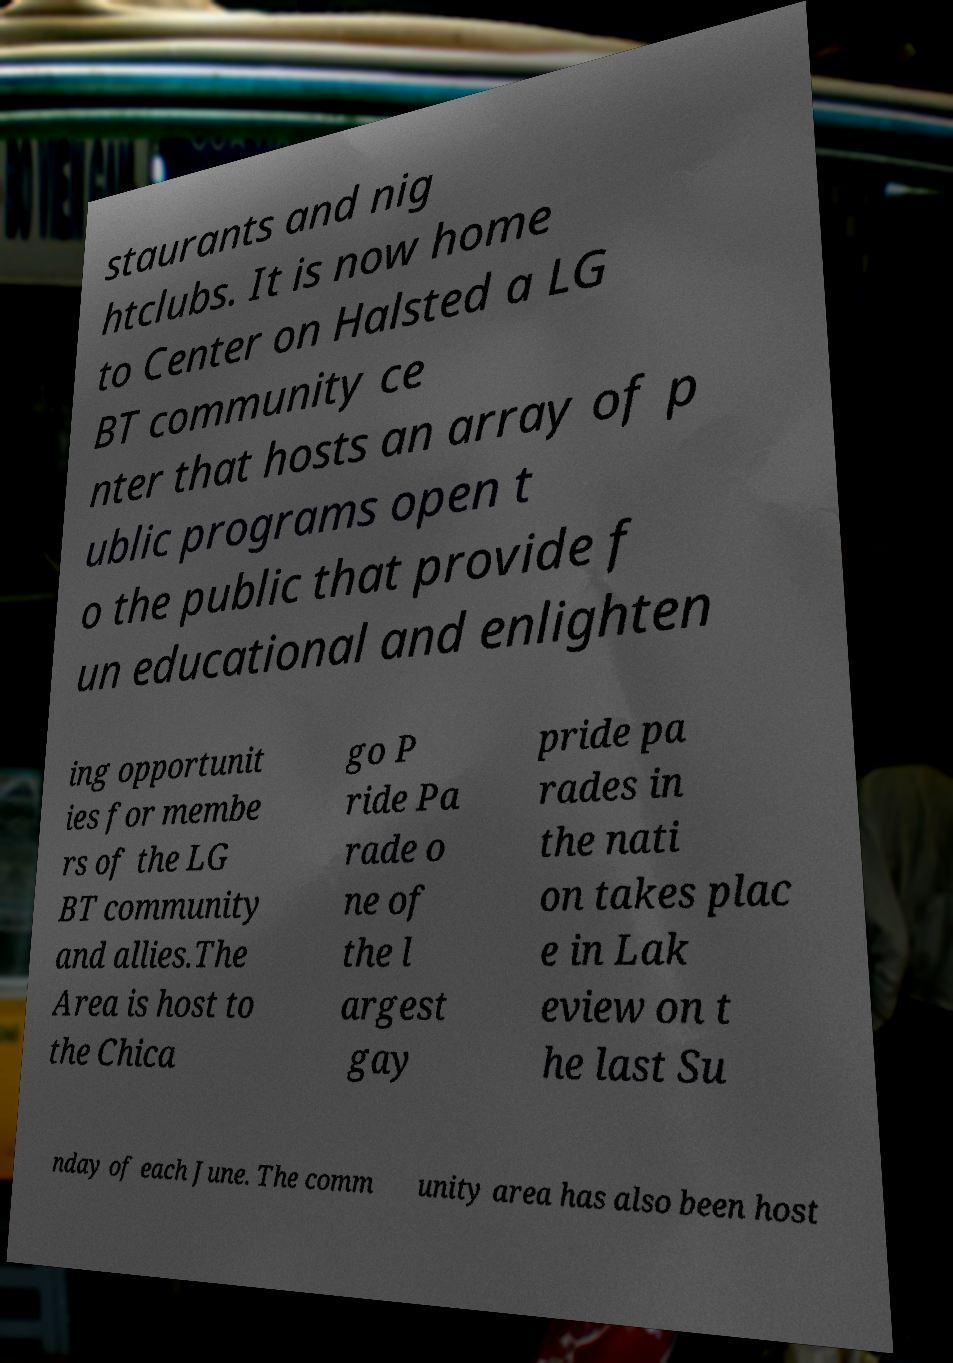What messages or text are displayed in this image? I need them in a readable, typed format. staurants and nig htclubs. It is now home to Center on Halsted a LG BT community ce nter that hosts an array of p ublic programs open t o the public that provide f un educational and enlighten ing opportunit ies for membe rs of the LG BT community and allies.The Area is host to the Chica go P ride Pa rade o ne of the l argest gay pride pa rades in the nati on takes plac e in Lak eview on t he last Su nday of each June. The comm unity area has also been host 